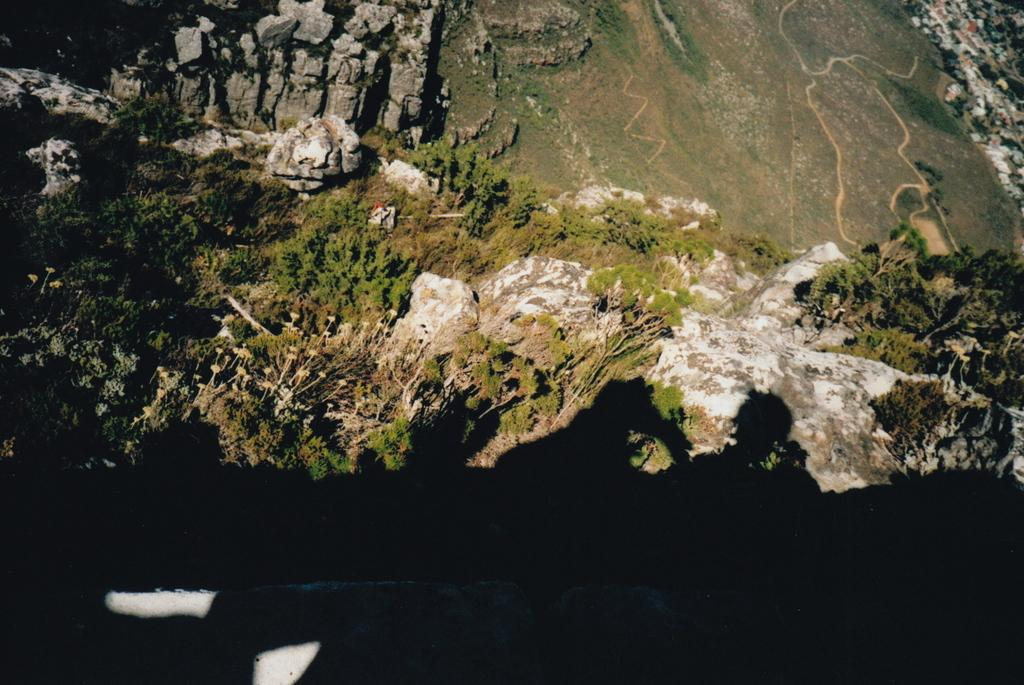What type of natural elements can be seen in the image? There are trees and rocks in the image. Can you describe the trees in the image? The provided facts do not give specific details about the trees, so we cannot describe them further. What other objects or features can be seen in the image? The provided facts only mention trees and rocks, so we cannot describe any other objects or features. What type of screw can be seen in the image? There is no screw present in the image; it only features trees and rocks. How does the taste of the trees in the image compare to that of the rocks? The provided facts do not give any information about the taste of the trees or rocks, so we cannot compare their tastes. 